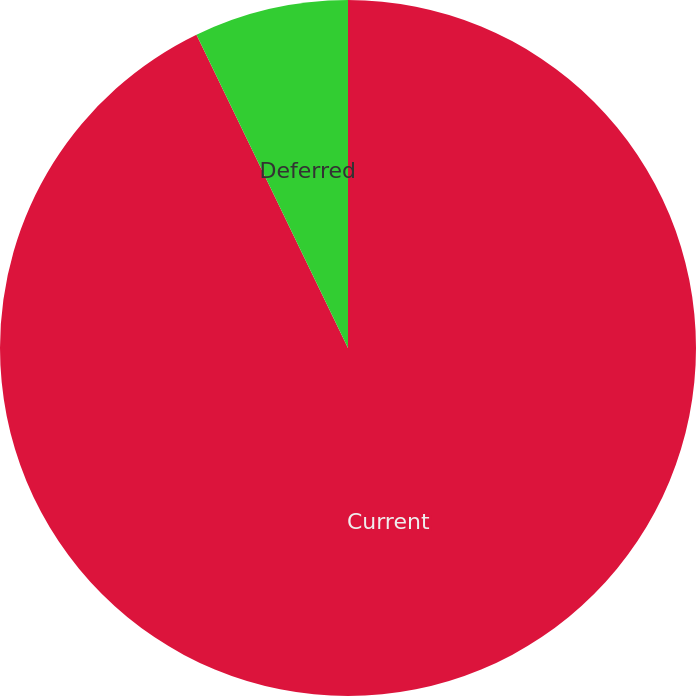Convert chart to OTSL. <chart><loc_0><loc_0><loc_500><loc_500><pie_chart><fcel>Current<fcel>Deferred<nl><fcel>92.83%<fcel>7.17%<nl></chart> 